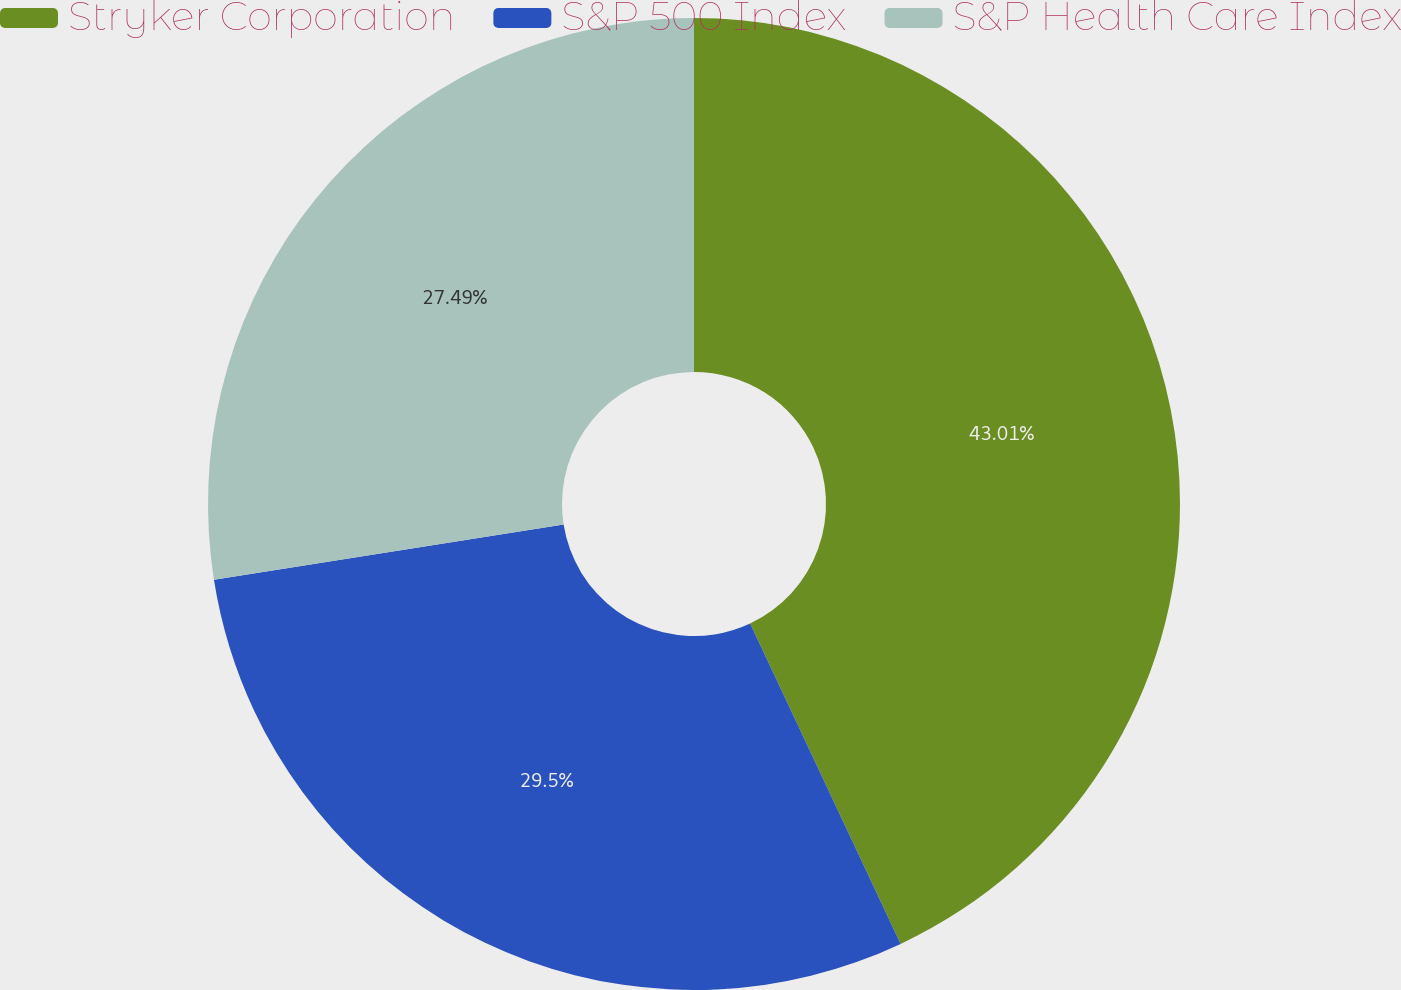<chart> <loc_0><loc_0><loc_500><loc_500><pie_chart><fcel>Stryker Corporation<fcel>S&P 500 Index<fcel>S&P Health Care Index<nl><fcel>43.01%<fcel>29.5%<fcel>27.49%<nl></chart> 